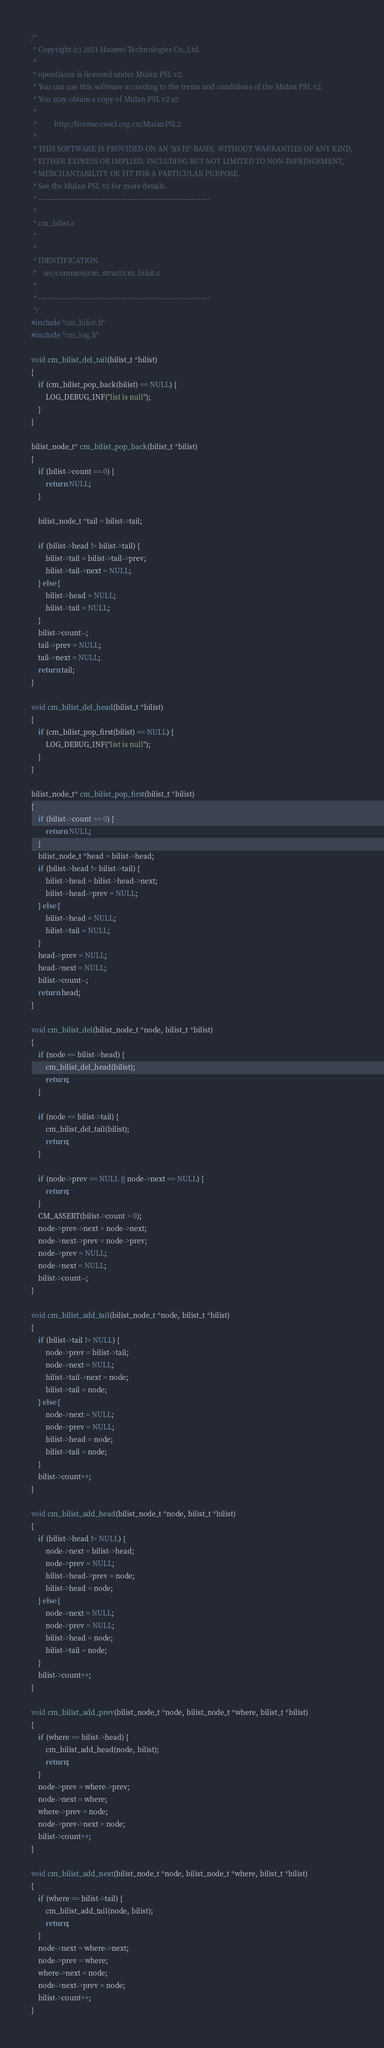Convert code to text. <code><loc_0><loc_0><loc_500><loc_500><_C_>/*
 * Copyright (c) 2021 Huawei Technologies Co.,Ltd.
 *
 * openGauss is licensed under Mulan PSL v2.
 * You can use this software according to the terms and conditions of the Mulan PSL v2.
 * You may obtain a copy of Mulan PSL v2 at:
 *
 *          http://license.coscl.org.cn/MulanPSL2
 *
 * THIS SOFTWARE IS PROVIDED ON AN "AS IS" BASIS, WITHOUT WARRANTIES OF ANY KIND,
 * EITHER EXPRESS OR IMPLIED, INCLUDING BUT NOT LIMITED TO NON-INFRINGEMENT,
 * MERCHANTABILITY OR FIT FOR A PARTICULAR PURPOSE.
 * See the Mulan PSL v2 for more details.
 * -------------------------------------------------------------------------
 *
 * cm_bilist.c
 *
 *
 * IDENTIFICATION
 *    src/common/cm_struct/cm_bilist.c
 *
 * -------------------------------------------------------------------------
 */
#include "cm_bilist.h"
#include "cm_log.h"

void cm_bilist_del_tail(bilist_t *bilist)
{
    if (cm_bilist_pop_back(bilist) == NULL) {
        LOG_DEBUG_INF("list is null");
    }
}

bilist_node_t* cm_bilist_pop_back(bilist_t *bilist)
{
    if (bilist->count == 0) {
        return NULL;
    }

    bilist_node_t *tail = bilist->tail;

    if (bilist->head != bilist->tail) {
        bilist->tail = bilist->tail->prev;
        bilist->tail->next = NULL;
    } else {
        bilist->head = NULL;
        bilist->tail = NULL;
    }
    bilist->count--;
    tail->prev = NULL;
    tail->next = NULL;
    return tail;
}

void cm_bilist_del_head(bilist_t *bilist)
{
    if (cm_bilist_pop_first(bilist) == NULL) {
        LOG_DEBUG_INF("list is null");
    }
}

bilist_node_t* cm_bilist_pop_first(bilist_t *bilist)
{
    if (bilist->count == 0) {
        return NULL;
    }
    bilist_node_t *head = bilist->head;
    if (bilist->head != bilist->tail) {
        bilist->head = bilist->head->next;
        bilist->head->prev = NULL;
    } else {
        bilist->head = NULL;
        bilist->tail = NULL;
    }
    head->prev = NULL;
    head->next = NULL;
    bilist->count--;
    return head;
}

void cm_bilist_del(bilist_node_t *node, bilist_t *bilist)
{
    if (node == bilist->head) {
        cm_bilist_del_head(bilist);
        return;
    }

    if (node == bilist->tail) {
        cm_bilist_del_tail(bilist);
        return;
    }

    if (node->prev == NULL || node->next == NULL) {
        return;
    }
    CM_ASSERT(bilist->count > 0);
    node->prev->next = node->next;
    node->next->prev = node->prev;
    node->prev = NULL;
    node->next = NULL;
    bilist->count--;
}

void cm_bilist_add_tail(bilist_node_t *node, bilist_t *bilist)
{
    if (bilist->tail != NULL) {
        node->prev = bilist->tail;
        node->next = NULL;
        bilist->tail->next = node;
        bilist->tail = node;
    } else {
        node->next = NULL;
        node->prev = NULL;
        bilist->head = node;
        bilist->tail = node;
    }
    bilist->count++;
}

void cm_bilist_add_head(bilist_node_t *node, bilist_t *bilist)
{
    if (bilist->head != NULL) {
        node->next = bilist->head;
        node->prev = NULL;
        bilist->head->prev = node;
        bilist->head = node;
    } else {
        node->next = NULL;
        node->prev = NULL;
        bilist->head = node;
        bilist->tail = node;
    }
    bilist->count++;
}

void cm_bilist_add_prev(bilist_node_t *node, bilist_node_t *where, bilist_t *bilist)
{
    if (where == bilist->head) {
        cm_bilist_add_head(node, bilist);
        return;
    }
    node->prev = where->prev;
    node->next = where;
    where->prev = node;
    node->prev->next = node;
    bilist->count++;
}

void cm_bilist_add_next(bilist_node_t *node, bilist_node_t *where, bilist_t *bilist)
{
    if (where == bilist->tail) {
        cm_bilist_add_tail(node, bilist);
        return;
    }
    node->next = where->next;
    node->prev = where;
    where->next = node;
    node->next->prev = node;
    bilist->count++;
}
</code> 